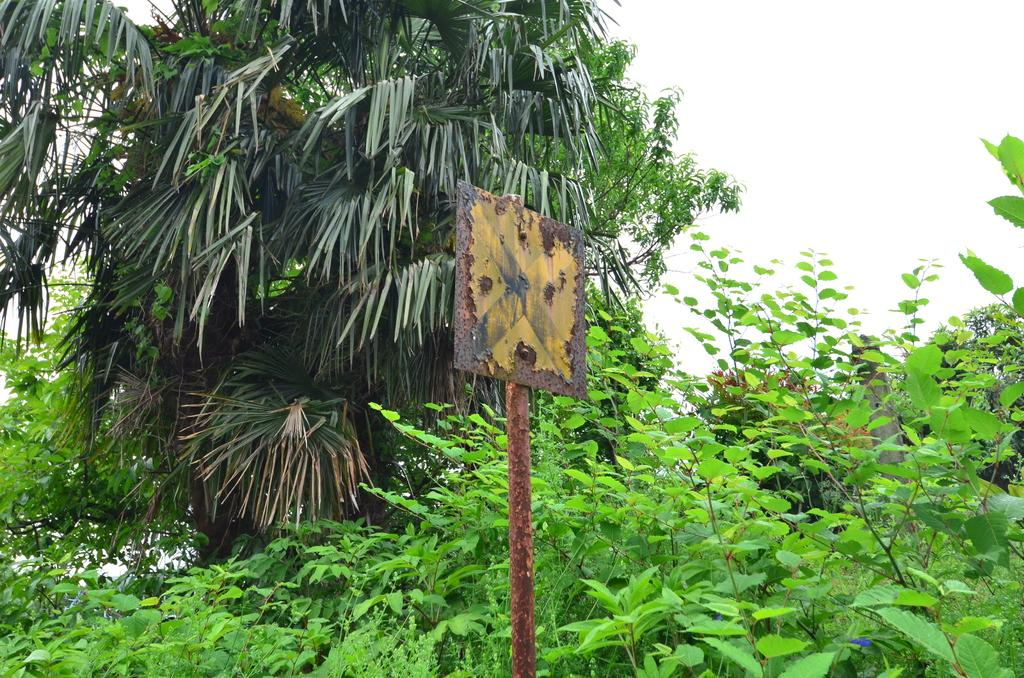What is the main object in the center of the image? There is a pole in the center of the image. What can be seen surrounding the pole in the image? There is greenery around the area of the image. How many bees are visible on the slope in the image? There are no bees or slopes present in the image; it features a pole with greenery surrounding it. 